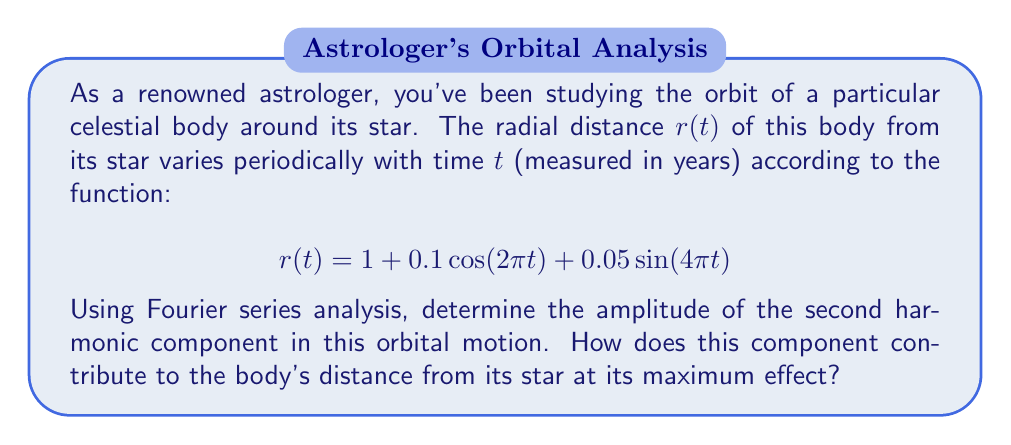Give your solution to this math problem. To solve this problem, we need to analyze the given function in terms of its Fourier series components:

1) The given function is already in the form of a Fourier series:

   $$r(t) = 1 + 0.1\cos(2\pi t) + 0.05\sin(4\pi t)$$

2) In a general Fourier series, we have:

   $$f(t) = a_0 + \sum_{n=1}^{\infty} [a_n\cos(2\pi nt) + b_n\sin(2\pi nt)]$$

3) Comparing our function to this general form:
   - $a_0 = 1$ (the constant term)
   - $a_1 = 0.1$ (coefficient of $\cos(2\pi t)$)
   - $b_1 = 0$ (no $\sin(2\pi t)$ term)
   - $a_2 = 0$ (no $\cos(4\pi t)$ term)
   - $b_2 = 0.05$ (coefficient of $\sin(4\pi t)$)

4) The second harmonic corresponds to $n=2$, which includes both $\cos(4\pi t)$ and $\sin(4\pi t)$ terms.

5) The amplitude of the second harmonic is given by $\sqrt{a_2^2 + b_2^2}$:

   $$\text{Amplitude} = \sqrt{0^2 + 0.05^2} = 0.05$$

6) At its maximum effect, this component contributes 0.05 units to the radial distance. This occurs when $\sin(4\pi t) = 1$, which happens at $t = 1/8, 5/8, 9/8,$ etc.
Answer: The amplitude of the second harmonic component is 0.05. At its maximum effect, it increases the celestial body's distance from its star by 0.05 units. 